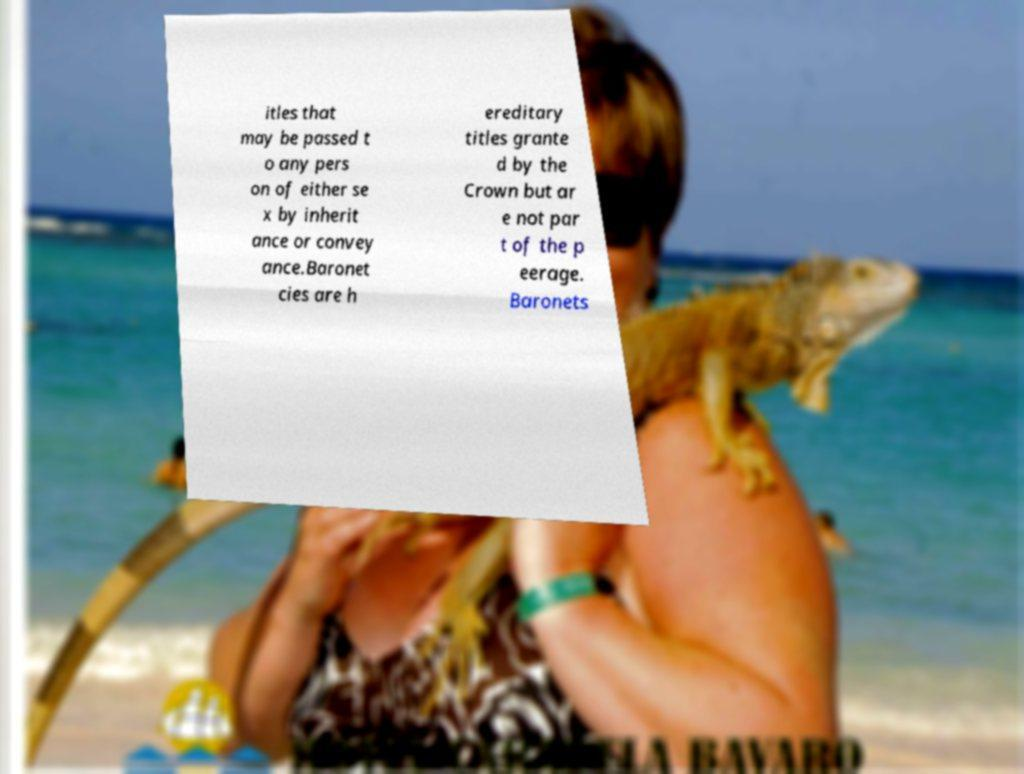What messages or text are displayed in this image? I need them in a readable, typed format. itles that may be passed t o any pers on of either se x by inherit ance or convey ance.Baronet cies are h ereditary titles grante d by the Crown but ar e not par t of the p eerage. Baronets 